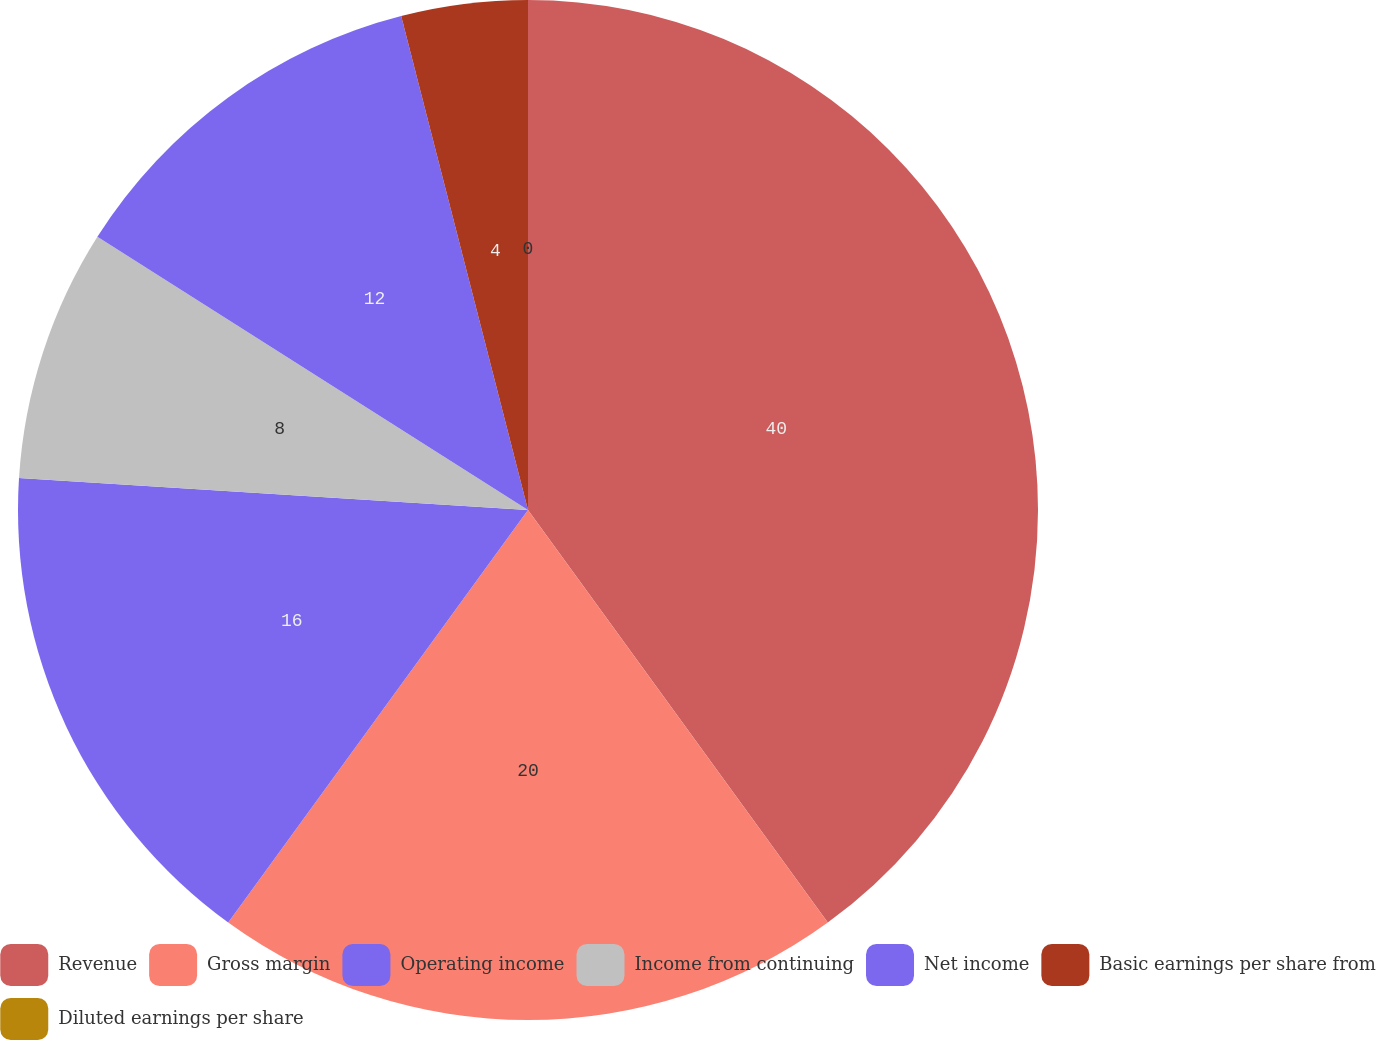<chart> <loc_0><loc_0><loc_500><loc_500><pie_chart><fcel>Revenue<fcel>Gross margin<fcel>Operating income<fcel>Income from continuing<fcel>Net income<fcel>Basic earnings per share from<fcel>Diluted earnings per share<nl><fcel>40.0%<fcel>20.0%<fcel>16.0%<fcel>8.0%<fcel>12.0%<fcel>4.0%<fcel>0.0%<nl></chart> 